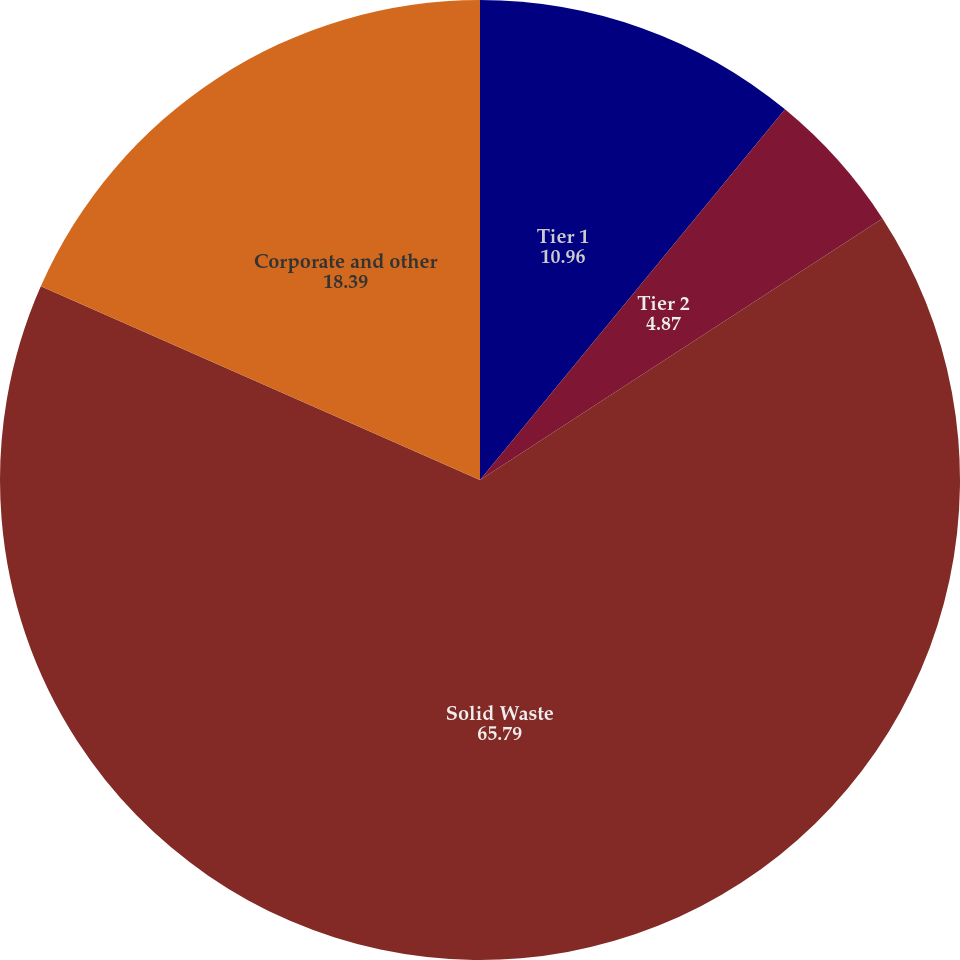Convert chart to OTSL. <chart><loc_0><loc_0><loc_500><loc_500><pie_chart><fcel>Tier 1<fcel>Tier 2<fcel>Solid Waste<fcel>Corporate and other<nl><fcel>10.96%<fcel>4.87%<fcel>65.79%<fcel>18.39%<nl></chart> 